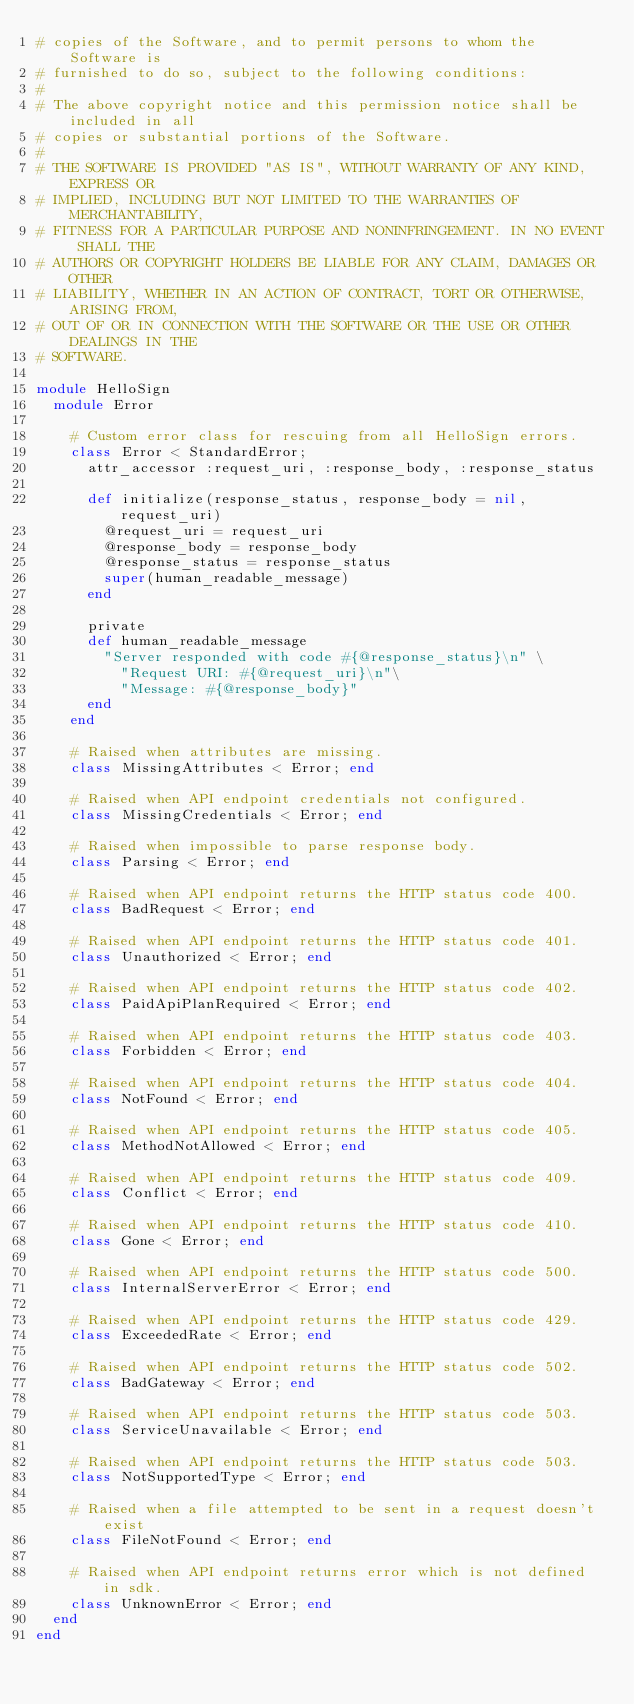<code> <loc_0><loc_0><loc_500><loc_500><_Ruby_># copies of the Software, and to permit persons to whom the Software is
# furnished to do so, subject to the following conditions:
#
# The above copyright notice and this permission notice shall be included in all
# copies or substantial portions of the Software.
#
# THE SOFTWARE IS PROVIDED "AS IS", WITHOUT WARRANTY OF ANY KIND, EXPRESS OR
# IMPLIED, INCLUDING BUT NOT LIMITED TO THE WARRANTIES OF MERCHANTABILITY,
# FITNESS FOR A PARTICULAR PURPOSE AND NONINFRINGEMENT. IN NO EVENT SHALL THE
# AUTHORS OR COPYRIGHT HOLDERS BE LIABLE FOR ANY CLAIM, DAMAGES OR OTHER
# LIABILITY, WHETHER IN AN ACTION OF CONTRACT, TORT OR OTHERWISE, ARISING FROM,
# OUT OF OR IN CONNECTION WITH THE SOFTWARE OR THE USE OR OTHER DEALINGS IN THE
# SOFTWARE.

module HelloSign
  module Error

    # Custom error class for rescuing from all HelloSign errors.
    class Error < StandardError;
      attr_accessor :request_uri, :response_body, :response_status

      def initialize(response_status, response_body = nil, request_uri)
        @request_uri = request_uri
        @response_body = response_body
        @response_status = response_status
        super(human_readable_message)
      end

      private
      def human_readable_message
        "Server responded with code #{@response_status}\n" \
          "Request URI: #{@request_uri}\n"\
          "Message: #{@response_body}"
      end
    end

    # Raised when attributes are missing.
    class MissingAttributes < Error; end

    # Raised when API endpoint credentials not configured.
    class MissingCredentials < Error; end

    # Raised when impossible to parse response body.
    class Parsing < Error; end

    # Raised when API endpoint returns the HTTP status code 400.
    class BadRequest < Error; end

    # Raised when API endpoint returns the HTTP status code 401.
    class Unauthorized < Error; end

    # Raised when API endpoint returns the HTTP status code 402.
    class PaidApiPlanRequired < Error; end

    # Raised when API endpoint returns the HTTP status code 403.
    class Forbidden < Error; end

    # Raised when API endpoint returns the HTTP status code 404.
    class NotFound < Error; end

    # Raised when API endpoint returns the HTTP status code 405.
    class MethodNotAllowed < Error; end

    # Raised when API endpoint returns the HTTP status code 409.
    class Conflict < Error; end

    # Raised when API endpoint returns the HTTP status code 410.
    class Gone < Error; end

    # Raised when API endpoint returns the HTTP status code 500.
    class InternalServerError < Error; end

    # Raised when API endpoint returns the HTTP status code 429.
    class ExceededRate < Error; end

    # Raised when API endpoint returns the HTTP status code 502.
    class BadGateway < Error; end

    # Raised when API endpoint returns the HTTP status code 503.
    class ServiceUnavailable < Error; end

    # Raised when API endpoint returns the HTTP status code 503.
    class NotSupportedType < Error; end

    # Raised when a file attempted to be sent in a request doesn't exist
    class FileNotFound < Error; end

    # Raised when API endpoint returns error which is not defined in sdk.
    class UnknownError < Error; end
  end
end
</code> 